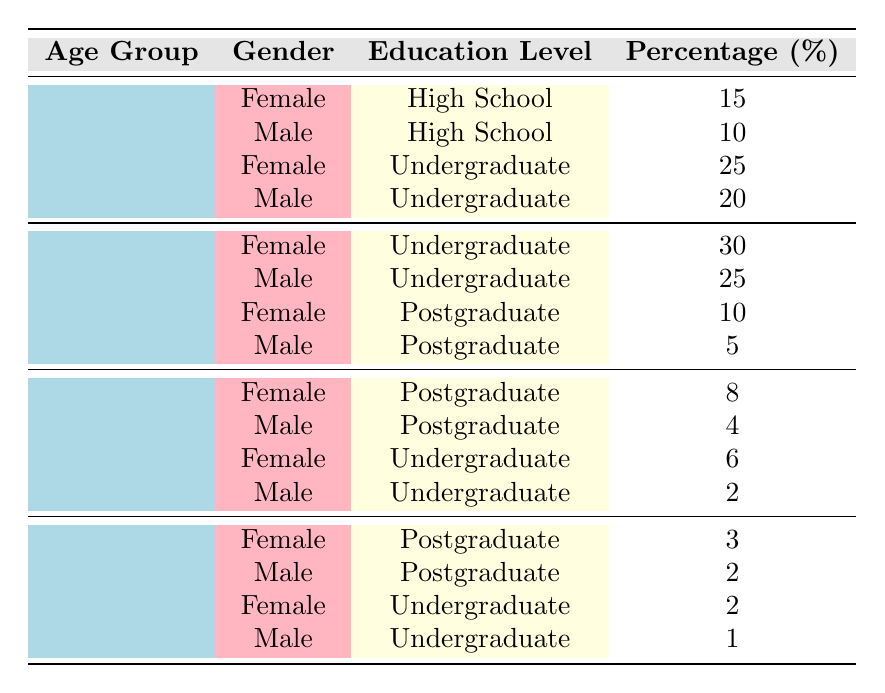What is the percentage of female volunteers in the age group 25-34 with an undergraduate education? According to the table, for the age group 25-34, the percentage of female volunteers with an undergraduate education is 30%.
Answer: 30% How many male volunteers in the age group 18-24 have a postgraduate education? The table shows that there are no male volunteers aged 18-24 with a postgraduate education, as this age group has only high school and undergraduate education percentages listed.
Answer: 0 Which gender has a higher percentage of volunteers with a postgraduate education in the age group 35-44? For the age group 35-44, the table shows that the percentage of female volunteers with postgraduate education is 8%, while for males it is 4%. Thus, females have a higher percentage of postgraduate education in this age group.
Answer: Female What is the total percentage of volunteers aged 45 and above with undergraduate education? In the age group 45+, the percentage of female volunteers with undergraduate education is 2% and for male volunteers, it is 1%. Adding these gives 2% + 1% = 3%.
Answer: 3% Is there a higher percentage of male volunteers with a high school education compared to female volunteers in the same category? The table indicates that 10% of male volunteers and 15% of female volunteers have a high school education in the age group 18-24. Therefore, there is a higher percentage of female volunteers in this category.
Answer: No What is the average percentage of undergraduate education among volunteers aged 25-34? In the age group 25-34, the percentages for undergraduate education are 30% (female) and 25% (male). To find the average, add these (30 + 25) = 55 and divide by the number of data points (2), which results in 55/2 = 27.5%.
Answer: 27.5% Which age group has the highest percentage of male volunteers at the postgraduate level? The table shows that in the age group 25-34, the percentage of male volunteers with a postgraduate education is 5%, and for the 35-44 age group, it is 4%. Since there are no postgraduate figures provided for 18-24 or 45+, the age group 25-34 has the highest percentage.
Answer: 25-34 How many female volunteers across all age groups have a total percentage of postgraduate education? The percentages for female volunteers with postgraduate education are 10% (25-34), 8% (35-44), and 3% (45+). Adding these percentages gives 10 + 8 + 3 = 21%.
Answer: 21% 